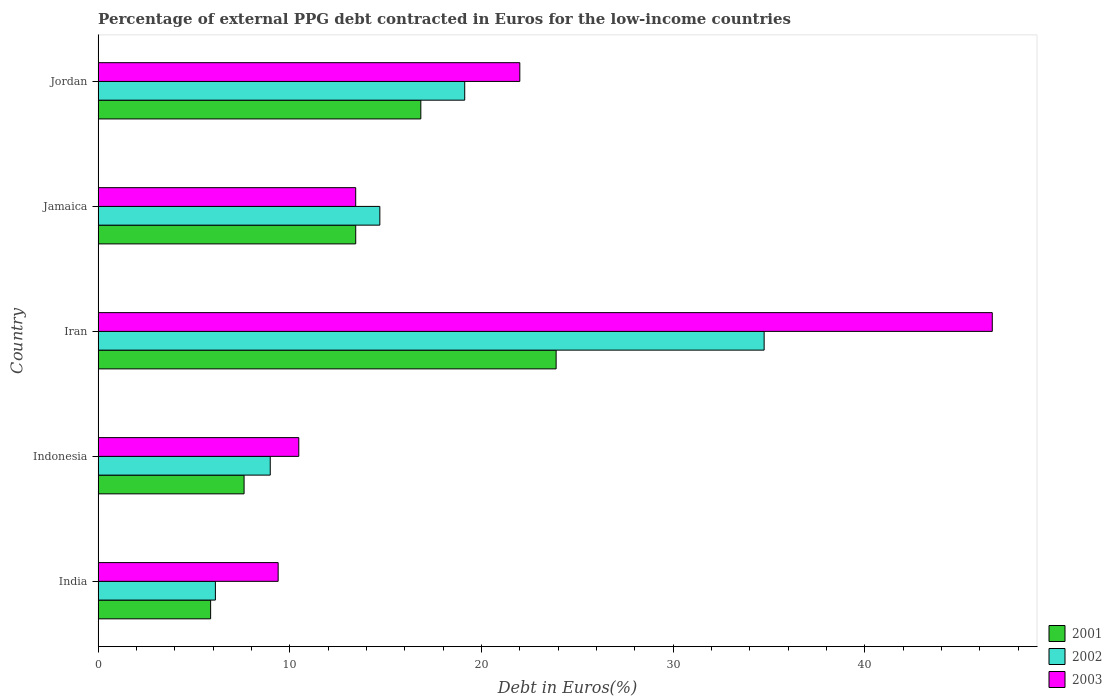How many groups of bars are there?
Offer a terse response. 5. Are the number of bars per tick equal to the number of legend labels?
Your answer should be compact. Yes. How many bars are there on the 2nd tick from the top?
Your response must be concise. 3. What is the label of the 2nd group of bars from the top?
Provide a succinct answer. Jamaica. What is the percentage of external PPG debt contracted in Euros in 2002 in Iran?
Your response must be concise. 34.75. Across all countries, what is the maximum percentage of external PPG debt contracted in Euros in 2002?
Ensure brevity in your answer.  34.75. Across all countries, what is the minimum percentage of external PPG debt contracted in Euros in 2003?
Offer a very short reply. 9.39. In which country was the percentage of external PPG debt contracted in Euros in 2001 maximum?
Ensure brevity in your answer.  Iran. What is the total percentage of external PPG debt contracted in Euros in 2003 in the graph?
Provide a succinct answer. 101.96. What is the difference between the percentage of external PPG debt contracted in Euros in 2003 in India and that in Jamaica?
Your response must be concise. -4.05. What is the difference between the percentage of external PPG debt contracted in Euros in 2002 in Jordan and the percentage of external PPG debt contracted in Euros in 2003 in Jamaica?
Provide a short and direct response. 5.69. What is the average percentage of external PPG debt contracted in Euros in 2001 per country?
Your response must be concise. 13.53. What is the difference between the percentage of external PPG debt contracted in Euros in 2002 and percentage of external PPG debt contracted in Euros in 2003 in India?
Provide a short and direct response. -3.27. What is the ratio of the percentage of external PPG debt contracted in Euros in 2003 in Iran to that in Jamaica?
Make the answer very short. 3.47. What is the difference between the highest and the second highest percentage of external PPG debt contracted in Euros in 2001?
Offer a very short reply. 7.06. What is the difference between the highest and the lowest percentage of external PPG debt contracted in Euros in 2003?
Make the answer very short. 37.26. In how many countries, is the percentage of external PPG debt contracted in Euros in 2001 greater than the average percentage of external PPG debt contracted in Euros in 2001 taken over all countries?
Your response must be concise. 2. Is the sum of the percentage of external PPG debt contracted in Euros in 2003 in Iran and Jordan greater than the maximum percentage of external PPG debt contracted in Euros in 2002 across all countries?
Your answer should be compact. Yes. Is it the case that in every country, the sum of the percentage of external PPG debt contracted in Euros in 2003 and percentage of external PPG debt contracted in Euros in 2001 is greater than the percentage of external PPG debt contracted in Euros in 2002?
Your answer should be compact. Yes. How many bars are there?
Ensure brevity in your answer.  15. What is the difference between two consecutive major ticks on the X-axis?
Ensure brevity in your answer.  10. Are the values on the major ticks of X-axis written in scientific E-notation?
Offer a very short reply. No. Does the graph contain any zero values?
Provide a short and direct response. No. Where does the legend appear in the graph?
Your answer should be very brief. Bottom right. How many legend labels are there?
Make the answer very short. 3. What is the title of the graph?
Provide a succinct answer. Percentage of external PPG debt contracted in Euros for the low-income countries. Does "1973" appear as one of the legend labels in the graph?
Your answer should be very brief. No. What is the label or title of the X-axis?
Your response must be concise. Debt in Euros(%). What is the Debt in Euros(%) in 2001 in India?
Provide a succinct answer. 5.87. What is the Debt in Euros(%) of 2002 in India?
Your answer should be compact. 6.12. What is the Debt in Euros(%) in 2003 in India?
Your answer should be compact. 9.39. What is the Debt in Euros(%) in 2001 in Indonesia?
Give a very brief answer. 7.62. What is the Debt in Euros(%) in 2002 in Indonesia?
Keep it short and to the point. 8.98. What is the Debt in Euros(%) of 2003 in Indonesia?
Provide a succinct answer. 10.47. What is the Debt in Euros(%) of 2001 in Iran?
Provide a short and direct response. 23.9. What is the Debt in Euros(%) in 2002 in Iran?
Offer a terse response. 34.75. What is the Debt in Euros(%) in 2003 in Iran?
Keep it short and to the point. 46.66. What is the Debt in Euros(%) in 2001 in Jamaica?
Make the answer very short. 13.44. What is the Debt in Euros(%) in 2002 in Jamaica?
Make the answer very short. 14.7. What is the Debt in Euros(%) of 2003 in Jamaica?
Give a very brief answer. 13.44. What is the Debt in Euros(%) in 2001 in Jordan?
Give a very brief answer. 16.84. What is the Debt in Euros(%) of 2002 in Jordan?
Offer a terse response. 19.13. What is the Debt in Euros(%) in 2003 in Jordan?
Your answer should be compact. 22. Across all countries, what is the maximum Debt in Euros(%) of 2001?
Give a very brief answer. 23.9. Across all countries, what is the maximum Debt in Euros(%) in 2002?
Give a very brief answer. 34.75. Across all countries, what is the maximum Debt in Euros(%) of 2003?
Provide a short and direct response. 46.66. Across all countries, what is the minimum Debt in Euros(%) in 2001?
Make the answer very short. 5.87. Across all countries, what is the minimum Debt in Euros(%) in 2002?
Ensure brevity in your answer.  6.12. Across all countries, what is the minimum Debt in Euros(%) in 2003?
Make the answer very short. 9.39. What is the total Debt in Euros(%) in 2001 in the graph?
Give a very brief answer. 67.66. What is the total Debt in Euros(%) in 2002 in the graph?
Keep it short and to the point. 83.68. What is the total Debt in Euros(%) of 2003 in the graph?
Your response must be concise. 101.96. What is the difference between the Debt in Euros(%) of 2001 in India and that in Indonesia?
Keep it short and to the point. -1.75. What is the difference between the Debt in Euros(%) in 2002 in India and that in Indonesia?
Keep it short and to the point. -2.86. What is the difference between the Debt in Euros(%) of 2003 in India and that in Indonesia?
Your response must be concise. -1.08. What is the difference between the Debt in Euros(%) of 2001 in India and that in Iran?
Make the answer very short. -18.03. What is the difference between the Debt in Euros(%) of 2002 in India and that in Iran?
Make the answer very short. -28.63. What is the difference between the Debt in Euros(%) of 2003 in India and that in Iran?
Give a very brief answer. -37.26. What is the difference between the Debt in Euros(%) in 2001 in India and that in Jamaica?
Give a very brief answer. -7.57. What is the difference between the Debt in Euros(%) in 2002 in India and that in Jamaica?
Keep it short and to the point. -8.58. What is the difference between the Debt in Euros(%) of 2003 in India and that in Jamaica?
Offer a terse response. -4.05. What is the difference between the Debt in Euros(%) in 2001 in India and that in Jordan?
Give a very brief answer. -10.97. What is the difference between the Debt in Euros(%) in 2002 in India and that in Jordan?
Provide a succinct answer. -13.01. What is the difference between the Debt in Euros(%) of 2003 in India and that in Jordan?
Your answer should be very brief. -12.61. What is the difference between the Debt in Euros(%) in 2001 in Indonesia and that in Iran?
Ensure brevity in your answer.  -16.28. What is the difference between the Debt in Euros(%) of 2002 in Indonesia and that in Iran?
Offer a very short reply. -25.77. What is the difference between the Debt in Euros(%) of 2003 in Indonesia and that in Iran?
Give a very brief answer. -36.19. What is the difference between the Debt in Euros(%) in 2001 in Indonesia and that in Jamaica?
Make the answer very short. -5.83. What is the difference between the Debt in Euros(%) of 2002 in Indonesia and that in Jamaica?
Offer a very short reply. -5.72. What is the difference between the Debt in Euros(%) in 2003 in Indonesia and that in Jamaica?
Offer a very short reply. -2.97. What is the difference between the Debt in Euros(%) of 2001 in Indonesia and that in Jordan?
Offer a very short reply. -9.22. What is the difference between the Debt in Euros(%) in 2002 in Indonesia and that in Jordan?
Provide a succinct answer. -10.15. What is the difference between the Debt in Euros(%) of 2003 in Indonesia and that in Jordan?
Make the answer very short. -11.53. What is the difference between the Debt in Euros(%) of 2001 in Iran and that in Jamaica?
Your answer should be very brief. 10.46. What is the difference between the Debt in Euros(%) in 2002 in Iran and that in Jamaica?
Offer a terse response. 20.05. What is the difference between the Debt in Euros(%) of 2003 in Iran and that in Jamaica?
Give a very brief answer. 33.22. What is the difference between the Debt in Euros(%) of 2001 in Iran and that in Jordan?
Your answer should be very brief. 7.06. What is the difference between the Debt in Euros(%) in 2002 in Iran and that in Jordan?
Make the answer very short. 15.62. What is the difference between the Debt in Euros(%) in 2003 in Iran and that in Jordan?
Provide a short and direct response. 24.65. What is the difference between the Debt in Euros(%) of 2001 in Jamaica and that in Jordan?
Provide a short and direct response. -3.4. What is the difference between the Debt in Euros(%) in 2002 in Jamaica and that in Jordan?
Ensure brevity in your answer.  -4.43. What is the difference between the Debt in Euros(%) of 2003 in Jamaica and that in Jordan?
Make the answer very short. -8.56. What is the difference between the Debt in Euros(%) in 2001 in India and the Debt in Euros(%) in 2002 in Indonesia?
Keep it short and to the point. -3.11. What is the difference between the Debt in Euros(%) of 2001 in India and the Debt in Euros(%) of 2003 in Indonesia?
Your response must be concise. -4.6. What is the difference between the Debt in Euros(%) of 2002 in India and the Debt in Euros(%) of 2003 in Indonesia?
Offer a very short reply. -4.35. What is the difference between the Debt in Euros(%) in 2001 in India and the Debt in Euros(%) in 2002 in Iran?
Your answer should be very brief. -28.88. What is the difference between the Debt in Euros(%) of 2001 in India and the Debt in Euros(%) of 2003 in Iran?
Provide a succinct answer. -40.78. What is the difference between the Debt in Euros(%) in 2002 in India and the Debt in Euros(%) in 2003 in Iran?
Provide a short and direct response. -40.54. What is the difference between the Debt in Euros(%) of 2001 in India and the Debt in Euros(%) of 2002 in Jamaica?
Keep it short and to the point. -8.83. What is the difference between the Debt in Euros(%) of 2001 in India and the Debt in Euros(%) of 2003 in Jamaica?
Offer a terse response. -7.57. What is the difference between the Debt in Euros(%) in 2002 in India and the Debt in Euros(%) in 2003 in Jamaica?
Provide a short and direct response. -7.32. What is the difference between the Debt in Euros(%) in 2001 in India and the Debt in Euros(%) in 2002 in Jordan?
Offer a terse response. -13.26. What is the difference between the Debt in Euros(%) in 2001 in India and the Debt in Euros(%) in 2003 in Jordan?
Your answer should be very brief. -16.13. What is the difference between the Debt in Euros(%) of 2002 in India and the Debt in Euros(%) of 2003 in Jordan?
Your answer should be compact. -15.88. What is the difference between the Debt in Euros(%) of 2001 in Indonesia and the Debt in Euros(%) of 2002 in Iran?
Your answer should be very brief. -27.14. What is the difference between the Debt in Euros(%) of 2001 in Indonesia and the Debt in Euros(%) of 2003 in Iran?
Keep it short and to the point. -39.04. What is the difference between the Debt in Euros(%) of 2002 in Indonesia and the Debt in Euros(%) of 2003 in Iran?
Keep it short and to the point. -37.67. What is the difference between the Debt in Euros(%) in 2001 in Indonesia and the Debt in Euros(%) in 2002 in Jamaica?
Make the answer very short. -7.08. What is the difference between the Debt in Euros(%) in 2001 in Indonesia and the Debt in Euros(%) in 2003 in Jamaica?
Ensure brevity in your answer.  -5.82. What is the difference between the Debt in Euros(%) of 2002 in Indonesia and the Debt in Euros(%) of 2003 in Jamaica?
Your answer should be very brief. -4.46. What is the difference between the Debt in Euros(%) in 2001 in Indonesia and the Debt in Euros(%) in 2002 in Jordan?
Make the answer very short. -11.51. What is the difference between the Debt in Euros(%) in 2001 in Indonesia and the Debt in Euros(%) in 2003 in Jordan?
Offer a very short reply. -14.39. What is the difference between the Debt in Euros(%) in 2002 in Indonesia and the Debt in Euros(%) in 2003 in Jordan?
Offer a very short reply. -13.02. What is the difference between the Debt in Euros(%) of 2001 in Iran and the Debt in Euros(%) of 2002 in Jamaica?
Provide a succinct answer. 9.2. What is the difference between the Debt in Euros(%) in 2001 in Iran and the Debt in Euros(%) in 2003 in Jamaica?
Ensure brevity in your answer.  10.46. What is the difference between the Debt in Euros(%) in 2002 in Iran and the Debt in Euros(%) in 2003 in Jamaica?
Your response must be concise. 21.31. What is the difference between the Debt in Euros(%) in 2001 in Iran and the Debt in Euros(%) in 2002 in Jordan?
Provide a short and direct response. 4.77. What is the difference between the Debt in Euros(%) in 2001 in Iran and the Debt in Euros(%) in 2003 in Jordan?
Ensure brevity in your answer.  1.89. What is the difference between the Debt in Euros(%) of 2002 in Iran and the Debt in Euros(%) of 2003 in Jordan?
Your response must be concise. 12.75. What is the difference between the Debt in Euros(%) in 2001 in Jamaica and the Debt in Euros(%) in 2002 in Jordan?
Keep it short and to the point. -5.69. What is the difference between the Debt in Euros(%) of 2001 in Jamaica and the Debt in Euros(%) of 2003 in Jordan?
Offer a terse response. -8.56. What is the difference between the Debt in Euros(%) in 2002 in Jamaica and the Debt in Euros(%) in 2003 in Jordan?
Your response must be concise. -7.3. What is the average Debt in Euros(%) in 2001 per country?
Ensure brevity in your answer.  13.53. What is the average Debt in Euros(%) in 2002 per country?
Keep it short and to the point. 16.74. What is the average Debt in Euros(%) of 2003 per country?
Your answer should be very brief. 20.39. What is the difference between the Debt in Euros(%) of 2001 and Debt in Euros(%) of 2002 in India?
Your answer should be very brief. -0.25. What is the difference between the Debt in Euros(%) of 2001 and Debt in Euros(%) of 2003 in India?
Your answer should be compact. -3.52. What is the difference between the Debt in Euros(%) in 2002 and Debt in Euros(%) in 2003 in India?
Offer a very short reply. -3.27. What is the difference between the Debt in Euros(%) in 2001 and Debt in Euros(%) in 2002 in Indonesia?
Your response must be concise. -1.37. What is the difference between the Debt in Euros(%) of 2001 and Debt in Euros(%) of 2003 in Indonesia?
Your response must be concise. -2.85. What is the difference between the Debt in Euros(%) in 2002 and Debt in Euros(%) in 2003 in Indonesia?
Provide a short and direct response. -1.49. What is the difference between the Debt in Euros(%) in 2001 and Debt in Euros(%) in 2002 in Iran?
Provide a short and direct response. -10.85. What is the difference between the Debt in Euros(%) in 2001 and Debt in Euros(%) in 2003 in Iran?
Offer a terse response. -22.76. What is the difference between the Debt in Euros(%) of 2002 and Debt in Euros(%) of 2003 in Iran?
Offer a terse response. -11.9. What is the difference between the Debt in Euros(%) of 2001 and Debt in Euros(%) of 2002 in Jamaica?
Offer a terse response. -1.26. What is the difference between the Debt in Euros(%) in 2001 and Debt in Euros(%) in 2003 in Jamaica?
Your answer should be compact. 0. What is the difference between the Debt in Euros(%) of 2002 and Debt in Euros(%) of 2003 in Jamaica?
Your answer should be very brief. 1.26. What is the difference between the Debt in Euros(%) of 2001 and Debt in Euros(%) of 2002 in Jordan?
Your response must be concise. -2.29. What is the difference between the Debt in Euros(%) in 2001 and Debt in Euros(%) in 2003 in Jordan?
Your response must be concise. -5.17. What is the difference between the Debt in Euros(%) of 2002 and Debt in Euros(%) of 2003 in Jordan?
Provide a short and direct response. -2.87. What is the ratio of the Debt in Euros(%) of 2001 in India to that in Indonesia?
Provide a short and direct response. 0.77. What is the ratio of the Debt in Euros(%) of 2002 in India to that in Indonesia?
Your answer should be compact. 0.68. What is the ratio of the Debt in Euros(%) of 2003 in India to that in Indonesia?
Ensure brevity in your answer.  0.9. What is the ratio of the Debt in Euros(%) in 2001 in India to that in Iran?
Your answer should be compact. 0.25. What is the ratio of the Debt in Euros(%) of 2002 in India to that in Iran?
Your answer should be very brief. 0.18. What is the ratio of the Debt in Euros(%) in 2003 in India to that in Iran?
Give a very brief answer. 0.2. What is the ratio of the Debt in Euros(%) in 2001 in India to that in Jamaica?
Provide a short and direct response. 0.44. What is the ratio of the Debt in Euros(%) of 2002 in India to that in Jamaica?
Provide a succinct answer. 0.42. What is the ratio of the Debt in Euros(%) of 2003 in India to that in Jamaica?
Ensure brevity in your answer.  0.7. What is the ratio of the Debt in Euros(%) of 2001 in India to that in Jordan?
Give a very brief answer. 0.35. What is the ratio of the Debt in Euros(%) of 2002 in India to that in Jordan?
Give a very brief answer. 0.32. What is the ratio of the Debt in Euros(%) in 2003 in India to that in Jordan?
Offer a terse response. 0.43. What is the ratio of the Debt in Euros(%) of 2001 in Indonesia to that in Iran?
Your response must be concise. 0.32. What is the ratio of the Debt in Euros(%) of 2002 in Indonesia to that in Iran?
Provide a short and direct response. 0.26. What is the ratio of the Debt in Euros(%) in 2003 in Indonesia to that in Iran?
Offer a very short reply. 0.22. What is the ratio of the Debt in Euros(%) of 2001 in Indonesia to that in Jamaica?
Keep it short and to the point. 0.57. What is the ratio of the Debt in Euros(%) of 2002 in Indonesia to that in Jamaica?
Make the answer very short. 0.61. What is the ratio of the Debt in Euros(%) in 2003 in Indonesia to that in Jamaica?
Give a very brief answer. 0.78. What is the ratio of the Debt in Euros(%) of 2001 in Indonesia to that in Jordan?
Your response must be concise. 0.45. What is the ratio of the Debt in Euros(%) of 2002 in Indonesia to that in Jordan?
Ensure brevity in your answer.  0.47. What is the ratio of the Debt in Euros(%) in 2003 in Indonesia to that in Jordan?
Your response must be concise. 0.48. What is the ratio of the Debt in Euros(%) of 2001 in Iran to that in Jamaica?
Provide a short and direct response. 1.78. What is the ratio of the Debt in Euros(%) in 2002 in Iran to that in Jamaica?
Make the answer very short. 2.36. What is the ratio of the Debt in Euros(%) of 2003 in Iran to that in Jamaica?
Make the answer very short. 3.47. What is the ratio of the Debt in Euros(%) of 2001 in Iran to that in Jordan?
Provide a short and direct response. 1.42. What is the ratio of the Debt in Euros(%) of 2002 in Iran to that in Jordan?
Your response must be concise. 1.82. What is the ratio of the Debt in Euros(%) in 2003 in Iran to that in Jordan?
Ensure brevity in your answer.  2.12. What is the ratio of the Debt in Euros(%) of 2001 in Jamaica to that in Jordan?
Provide a short and direct response. 0.8. What is the ratio of the Debt in Euros(%) in 2002 in Jamaica to that in Jordan?
Your answer should be very brief. 0.77. What is the ratio of the Debt in Euros(%) in 2003 in Jamaica to that in Jordan?
Make the answer very short. 0.61. What is the difference between the highest and the second highest Debt in Euros(%) in 2001?
Make the answer very short. 7.06. What is the difference between the highest and the second highest Debt in Euros(%) in 2002?
Offer a very short reply. 15.62. What is the difference between the highest and the second highest Debt in Euros(%) in 2003?
Your answer should be compact. 24.65. What is the difference between the highest and the lowest Debt in Euros(%) of 2001?
Offer a very short reply. 18.03. What is the difference between the highest and the lowest Debt in Euros(%) in 2002?
Your response must be concise. 28.63. What is the difference between the highest and the lowest Debt in Euros(%) in 2003?
Your response must be concise. 37.26. 